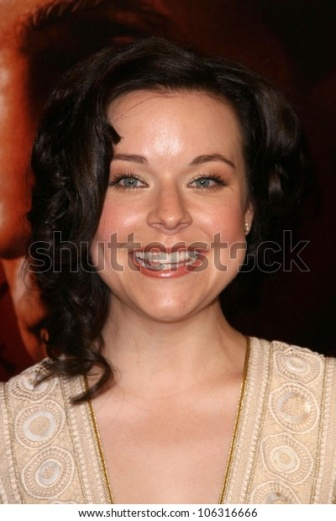Write a detailed description of the given image. In the image, the central figure is a woman with dark brown hair, styled in loose curls that gracefully fall around her shoulders. Her bright smile is radiant and engaging, capturing the viewer's attention immediately. She is wearing a beige dress adorned with circular, textured patterns that add depth and intrigue to her attire. The intricate design of the dress adds a unique flair to her appearance, complementing her cheerful demeanor.

Her ears are adorned with small, subtle earrings that enhance her elegant look without overshadowing her natural beauty. The background is a blurred red, suggesting a lively, possibly glamorous event, such as a red carpet occasion. The red hue contrasts sharply with the woman's light-colored dress, allowing her to stand out even more prominently in the image.

Despite the background blur, the focus remains sharply on the woman's joyous expression and detailed attire. The image captures a moment of genuine happiness and grace, with the woman's smile and intricate dress as the main highlights of this engaging photograph. 